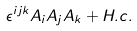<formula> <loc_0><loc_0><loc_500><loc_500>\epsilon ^ { i j k } A _ { i } A _ { j } A _ { k } + H . c .</formula> 